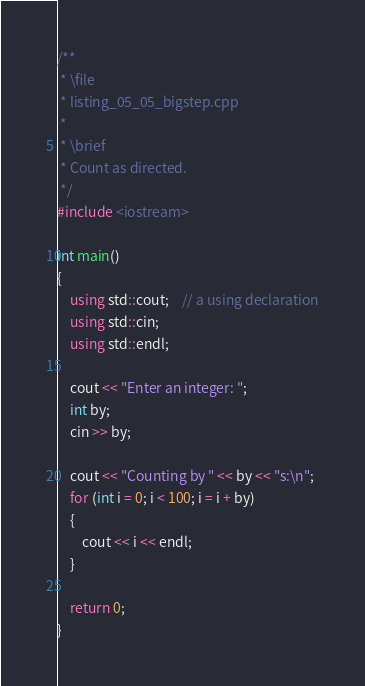Convert code to text. <code><loc_0><loc_0><loc_500><loc_500><_C++_>/**
 * \file
 * listing_05_05_bigstep.cpp
 *
 * \brief
 * Count as directed.
 */
#include <iostream>

int main()
{
	using std::cout;    // a using declaration
	using std::cin;
	using std::endl;

	cout << "Enter an integer: ";
	int by;
	cin >> by;

	cout << "Counting by " << by << "s:\n";
	for (int i = 0; i < 100; i = i + by)
	{
		cout << i << endl;
	}

	return 0;
}
</code> 